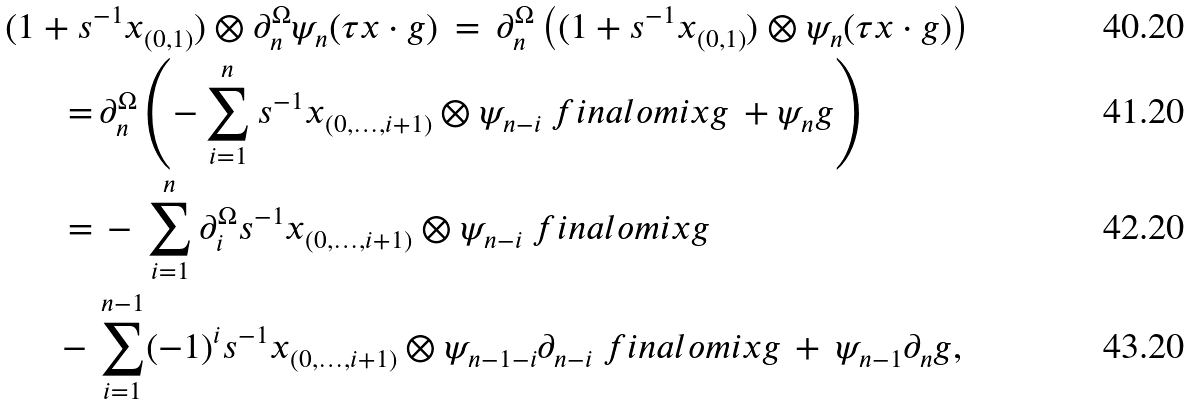Convert formula to latex. <formula><loc_0><loc_0><loc_500><loc_500>( 1 + s & ^ { - 1 } x _ { ( 0 , 1 ) } ) \otimes \partial ^ { \Omega } _ { n } \psi _ { n } ( \tau x \cdot g ) \, = \, \partial ^ { \Omega } _ { n } \left ( ( 1 + s ^ { - 1 } x _ { ( 0 , 1 ) } ) \otimes \psi _ { n } ( \tau x \cdot g ) \right ) \\ = & \, \partial ^ { \Omega } _ { n } \left ( - \sum _ { i = 1 } ^ { n } s ^ { - 1 } x _ { ( 0 , \dots , i + 1 ) } \otimes \psi _ { n - i } \ f i n a l o m i x g \, + \psi _ { n } g \right ) \\ = & \, - \, \sum _ { i = 1 } ^ { n } \partial ^ { \Omega } _ { i } s ^ { - 1 } x _ { ( 0 , \dots , i + 1 ) } \otimes \psi _ { n - i } \ f i n a l o m i x g \\ \, - \, & \sum _ { i = 1 } ^ { n - 1 } ( - 1 ) ^ { i } s ^ { - 1 } x _ { ( 0 , \dots , i + 1 ) } \otimes \psi _ { n - 1 - i } \partial _ { n - i } \ f i n a l o m i x g \, + \, \psi _ { n - 1 } \partial _ { n } g ,</formula> 